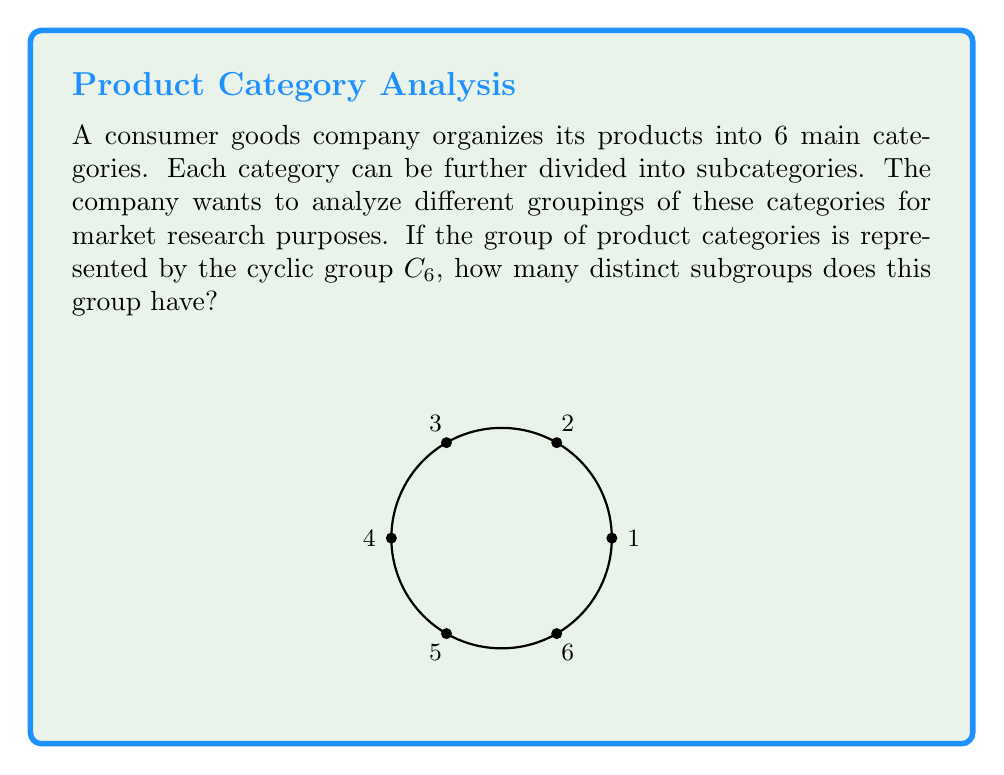Show me your answer to this math problem. To solve this problem, we need to follow these steps:

1) First, recall that $C_6$ is a cyclic group of order 6. It can be generated by a single element, let's call it $a$, such that $C_6 = \{e, a, a^2, a^3, a^4, a^5\}$, where $e$ is the identity element.

2) The number of subgroups in a cyclic group is related to the divisors of the group's order. For $C_6$, we need to find the divisors of 6.

3) The divisors of 6 are: 1, 2, 3, and 6.

4) For each divisor $d$ of 6, there is exactly one subgroup of order $d$ in $C_6$. Let's identify these subgroups:

   - For $d=1$: $\{e\}$ (the trivial subgroup)
   - For $d=2$: $\{e, a^3\}$
   - For $d=3$: $\{e, a^2, a^4\}$
   - For $d=6$: $\{e, a, a^2, a^3, a^4, a^5\}$ (the entire group)

5) Therefore, the number of distinct subgroups is equal to the number of divisors of 6, which is 4.

This result means that the company can analyze its product categories in 4 distinct groupings, ranging from considering each category individually to considering all categories together.
Answer: 4 subgroups 